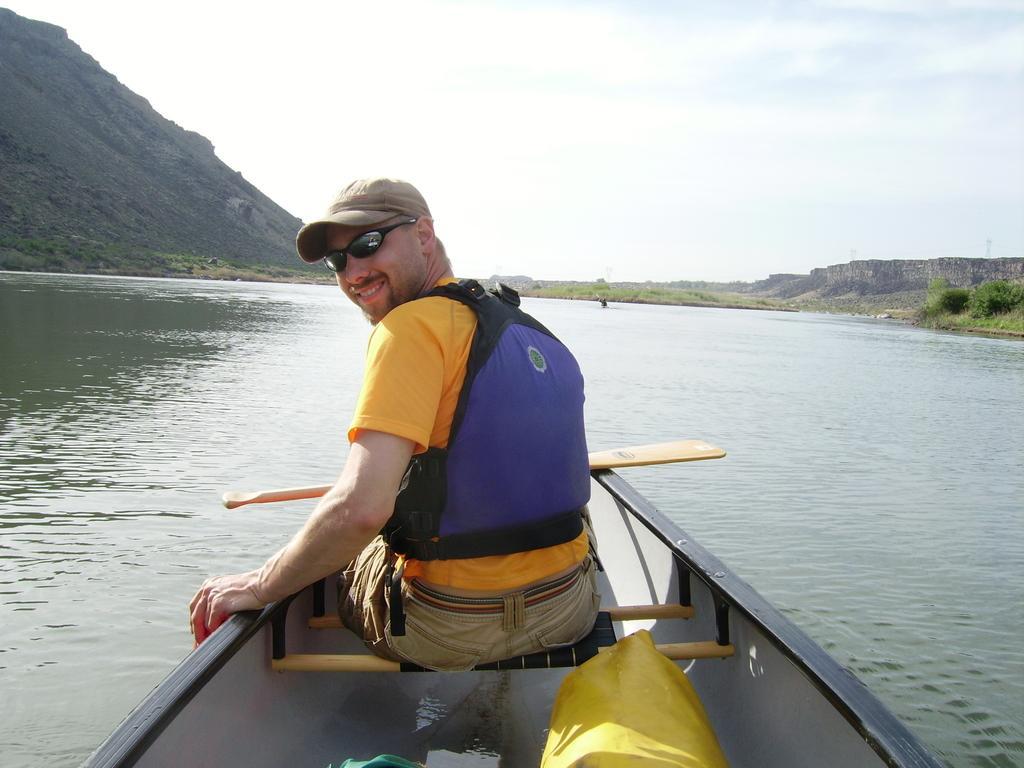How would you summarize this image in a sentence or two? A man is sitting in the boat, this is water and a sky. 